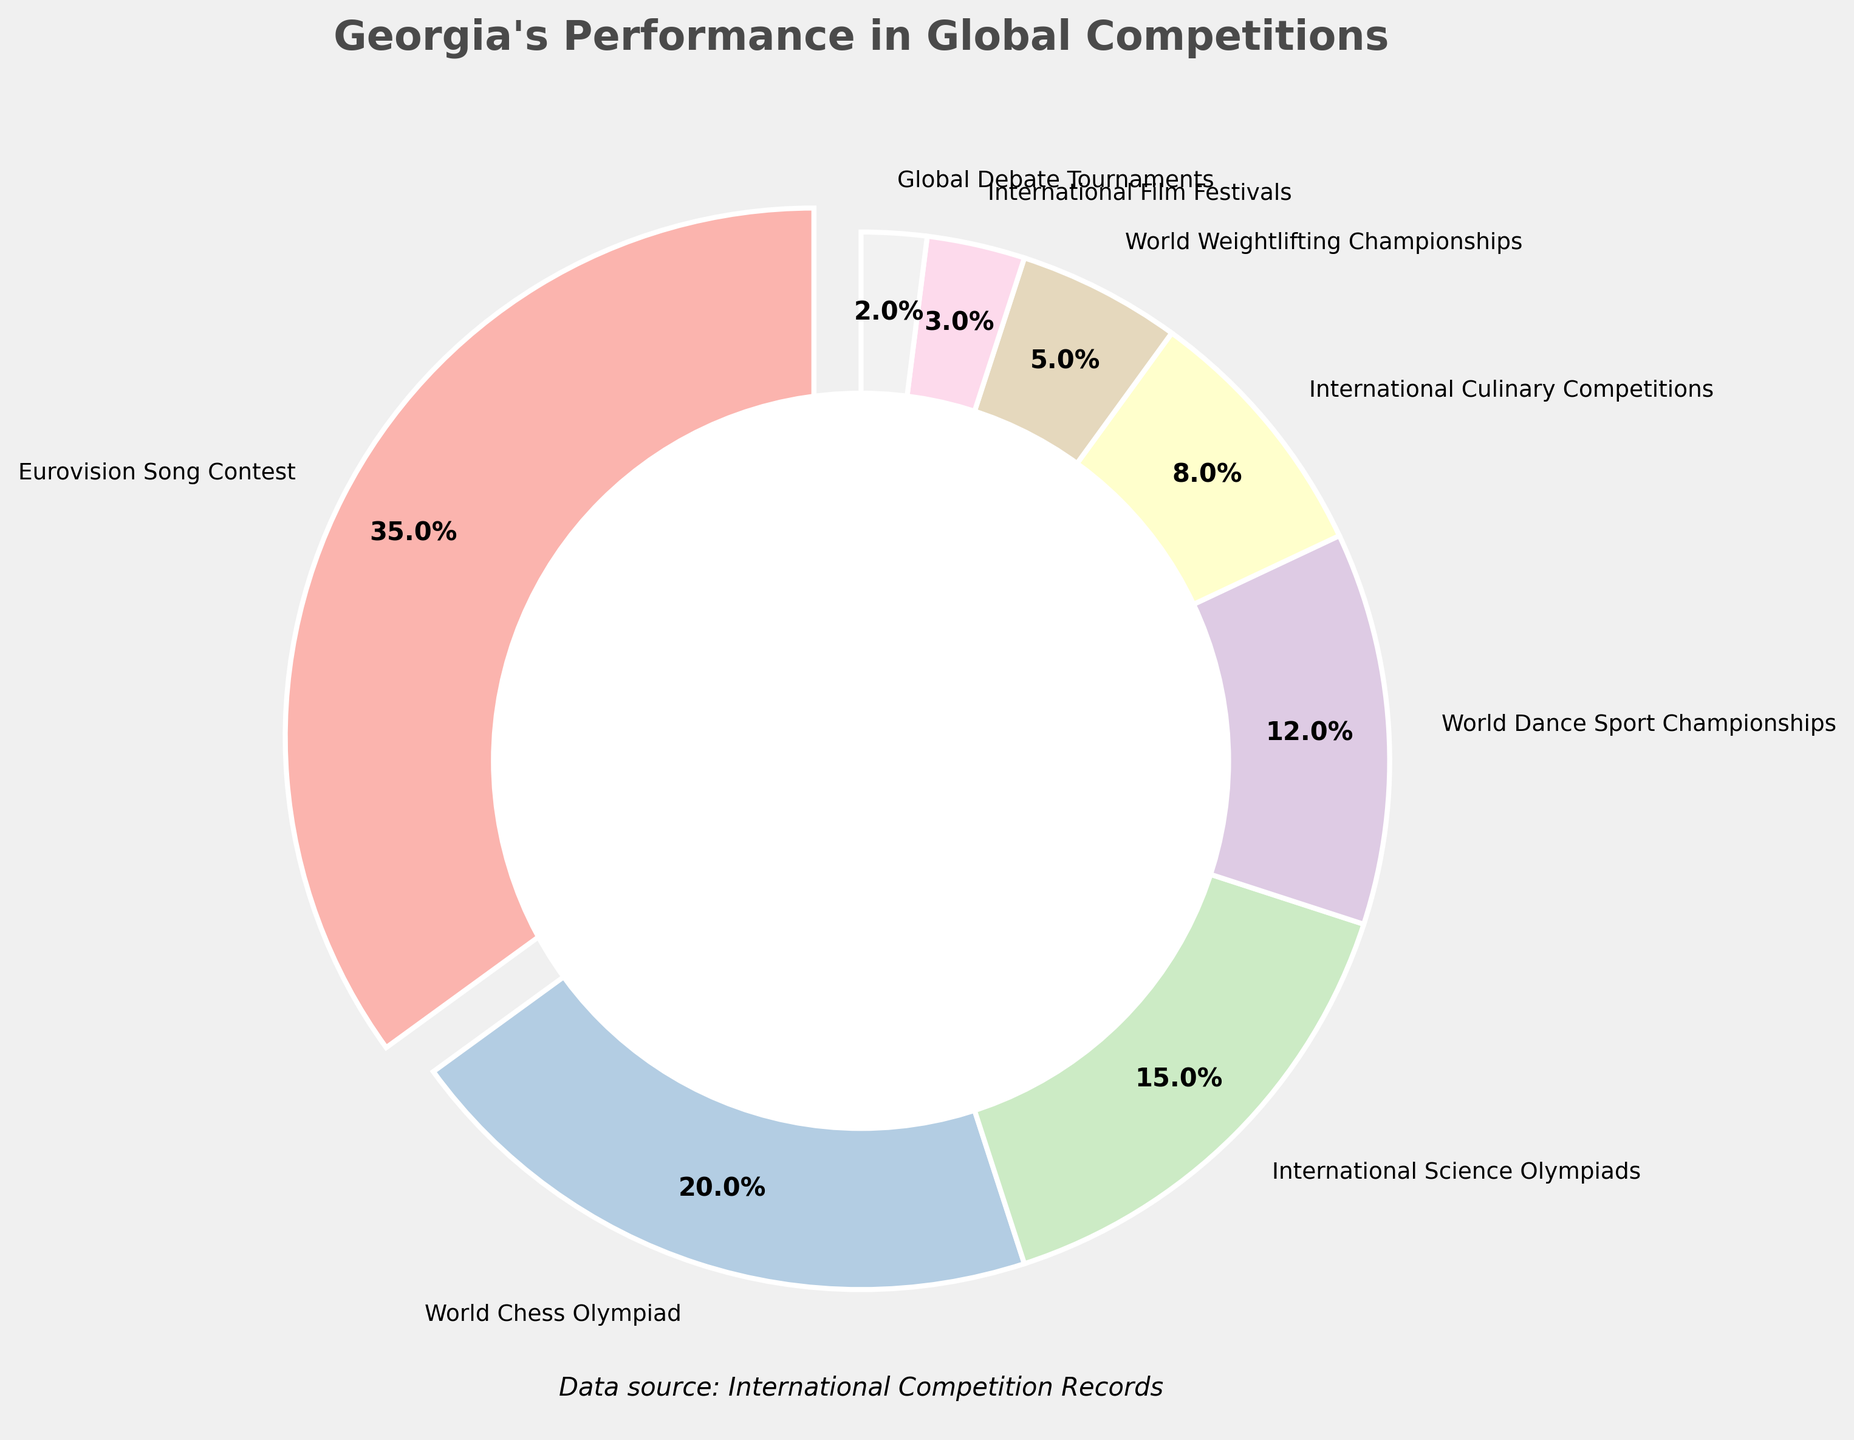What is the percentage of Georgia's performance in the Eurovision Song Contest? The visual attribute for the Eurovision Song Contest slice shows "35%" next to its label, indicating its percentage.
Answer: 35% What is the combined percentage of Georgia's performances in the International Science Olympiads and International Culinary Competitions? Add the percentages for International Science Olympiads (15%) and International Culinary Competitions (8%). 15 + 8 = 23.
Answer: 23% Which category has a greater percentage, World Weightlifting Championships or International Film Festivals? Compare the percentages of World Weightlifting Championships (5%) and International Film Festivals (3%). 5 is greater than 3.
Answer: World Weightlifting Championships By how much does the percentage of Georgia's performance in the World Chess Olympiad exceed that in the World Dance Sport Championships? Subtract the percentage of World Dance Sport Championships (12%) from World Chess Olympiad (20%). 20 - 12 = 8.
Answer: 8% Which performance category is featured with the highest percentage, and what is that percentage? The largest slice in the pie chart is labeled "Eurovision Song Contest" with a percentage of 35%.
Answer: Eurovision Song Contest, 35% What is the total percentage of Georgia's performances in categories other than the Eurovision Song Contest? Subtract the percentage of the Eurovision Song Contest (35%) from 100%. 100 - 35 = 65.
Answer: 65% Arrange the categories in descending order of their percentages. From largest to smallest percentage: Eurovision Song Contest (35%), World Chess Olympiad (20%), International Science Olympiads (15%), World Dance Sport Championships (12%), International Culinary Competitions (8%), World Weightlifting Championships (5%), International Film Festivals (3%), Global Debate Tournaments (2%).
Answer: Eurovision Song Contest, World Chess Olympiad, International Science Olympiads, World Dance Sport Championships, International Culinary Competitions, World Weightlifting Championships, International Film Festivals, Global Debate Tournaments How many categories have a percentage less than 10%? Count the categories where the percentage is less than 10%: International Culinary Competitions (8%), World Weightlifting Championships (5%), International Film Festivals (3%), Global Debate Tournaments (2%). There are 4 such categories.
Answer: 4 